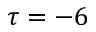Convert formula to latex. <formula><loc_0><loc_0><loc_500><loc_500>\tau = - 6</formula> 